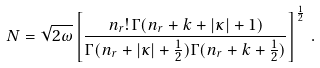<formula> <loc_0><loc_0><loc_500><loc_500>N = \sqrt { 2 \omega } \left [ \frac { n _ { r } ! \, \Gamma ( n _ { r } + k + | \kappa | + 1 ) } { \Gamma ( n _ { r } + | \kappa | + \frac { 1 } { 2 } ) \Gamma ( n _ { r } + k + \frac { 1 } { 2 } ) } \right ] ^ { \frac { 1 } { 2 } } \, .</formula> 